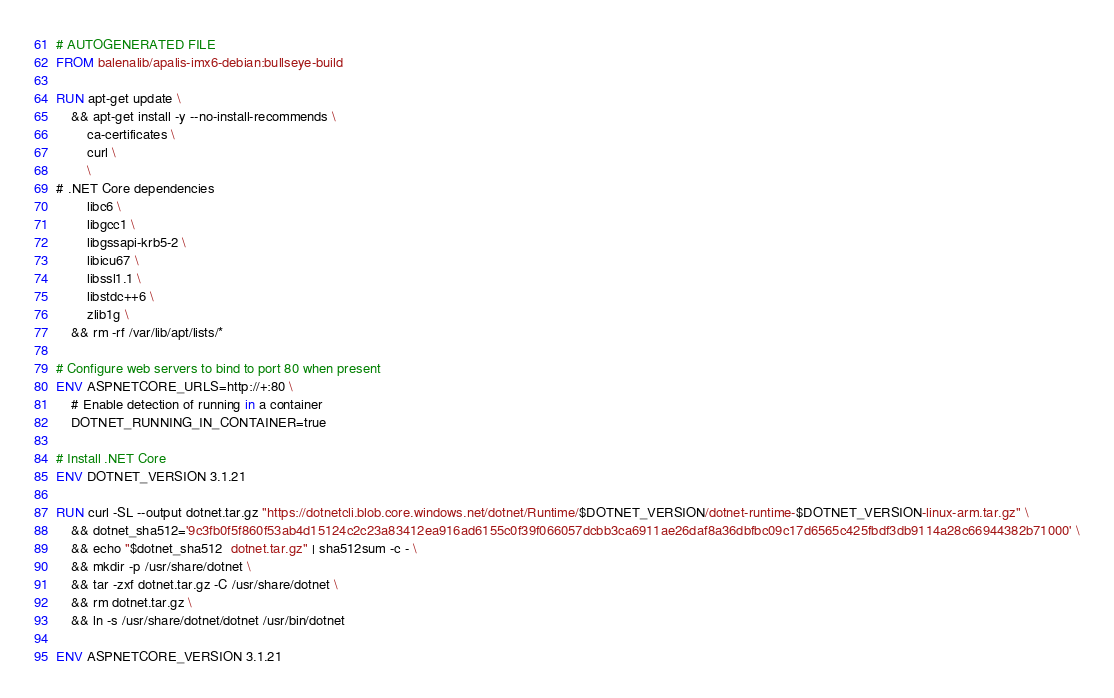Convert code to text. <code><loc_0><loc_0><loc_500><loc_500><_Dockerfile_># AUTOGENERATED FILE
FROM balenalib/apalis-imx6-debian:bullseye-build

RUN apt-get update \
    && apt-get install -y --no-install-recommends \
        ca-certificates \
        curl \
        \
# .NET Core dependencies
        libc6 \
        libgcc1 \
        libgssapi-krb5-2 \
        libicu67 \
        libssl1.1 \
        libstdc++6 \
        zlib1g \
    && rm -rf /var/lib/apt/lists/*

# Configure web servers to bind to port 80 when present
ENV ASPNETCORE_URLS=http://+:80 \
    # Enable detection of running in a container
    DOTNET_RUNNING_IN_CONTAINER=true

# Install .NET Core
ENV DOTNET_VERSION 3.1.21

RUN curl -SL --output dotnet.tar.gz "https://dotnetcli.blob.core.windows.net/dotnet/Runtime/$DOTNET_VERSION/dotnet-runtime-$DOTNET_VERSION-linux-arm.tar.gz" \
    && dotnet_sha512='9c3fb0f5f860f53ab4d15124c2c23a83412ea916ad6155c0f39f066057dcbb3ca6911ae26daf8a36dbfbc09c17d6565c425fbdf3db9114a28c66944382b71000' \
    && echo "$dotnet_sha512  dotnet.tar.gz" | sha512sum -c - \
    && mkdir -p /usr/share/dotnet \
    && tar -zxf dotnet.tar.gz -C /usr/share/dotnet \
    && rm dotnet.tar.gz \
    && ln -s /usr/share/dotnet/dotnet /usr/bin/dotnet

ENV ASPNETCORE_VERSION 3.1.21
</code> 